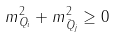<formula> <loc_0><loc_0><loc_500><loc_500>m _ { Q _ { i } } ^ { 2 } + m _ { \bar { Q } _ { j } } ^ { 2 } \geq 0</formula> 